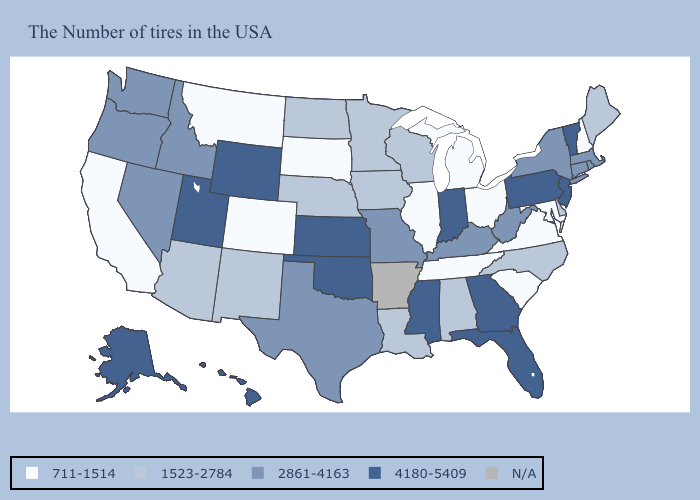What is the value of Michigan?
Quick response, please. 711-1514. What is the highest value in states that border New York?
Keep it brief. 4180-5409. Does the map have missing data?
Quick response, please. Yes. Which states hav the highest value in the MidWest?
Answer briefly. Indiana, Kansas. What is the value of Massachusetts?
Answer briefly. 2861-4163. Does Maryland have the lowest value in the South?
Short answer required. Yes. Which states hav the highest value in the West?
Short answer required. Wyoming, Utah, Alaska, Hawaii. What is the value of Minnesota?
Be succinct. 1523-2784. What is the value of Alaska?
Be succinct. 4180-5409. Which states have the lowest value in the USA?
Quick response, please. New Hampshire, Maryland, Virginia, South Carolina, Ohio, Michigan, Tennessee, Illinois, South Dakota, Colorado, Montana, California. Name the states that have a value in the range 1523-2784?
Be succinct. Maine, Delaware, North Carolina, Alabama, Wisconsin, Louisiana, Minnesota, Iowa, Nebraska, North Dakota, New Mexico, Arizona. Does Kentucky have the highest value in the South?
Concise answer only. No. What is the value of Hawaii?
Write a very short answer. 4180-5409. 